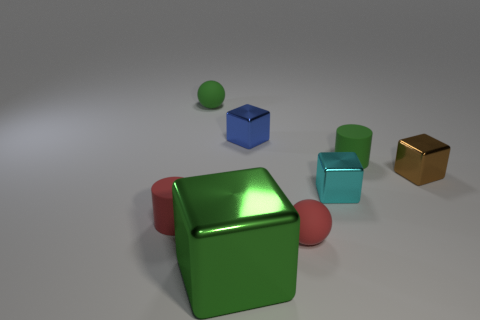Are there any other things that have the same size as the green block?
Your answer should be very brief. No. There is a small cylinder that is right of the tiny block behind the small brown object; are there any cyan metal objects that are to the right of it?
Provide a short and direct response. No. There is a red matte ball; are there any cyan shiny objects behind it?
Your response must be concise. Yes. Is there a small block that has the same color as the large metal thing?
Offer a very short reply. No. What number of small objects are either red rubber things or red cylinders?
Keep it short and to the point. 2. Do the tiny cylinder in front of the small brown metal thing and the big thing have the same material?
Keep it short and to the point. No. What is the shape of the small red matte object to the left of the small sphere to the left of the small metal object that is behind the small brown metallic thing?
Provide a succinct answer. Cylinder. What number of blue objects are big shiny cubes or small rubber cylinders?
Give a very brief answer. 0. Are there the same number of tiny metal blocks on the left side of the green cube and small red matte cylinders to the left of the red rubber ball?
Give a very brief answer. No. There is a tiny green object right of the green rubber sphere; is it the same shape as the tiny green thing behind the green cylinder?
Your answer should be compact. No. 